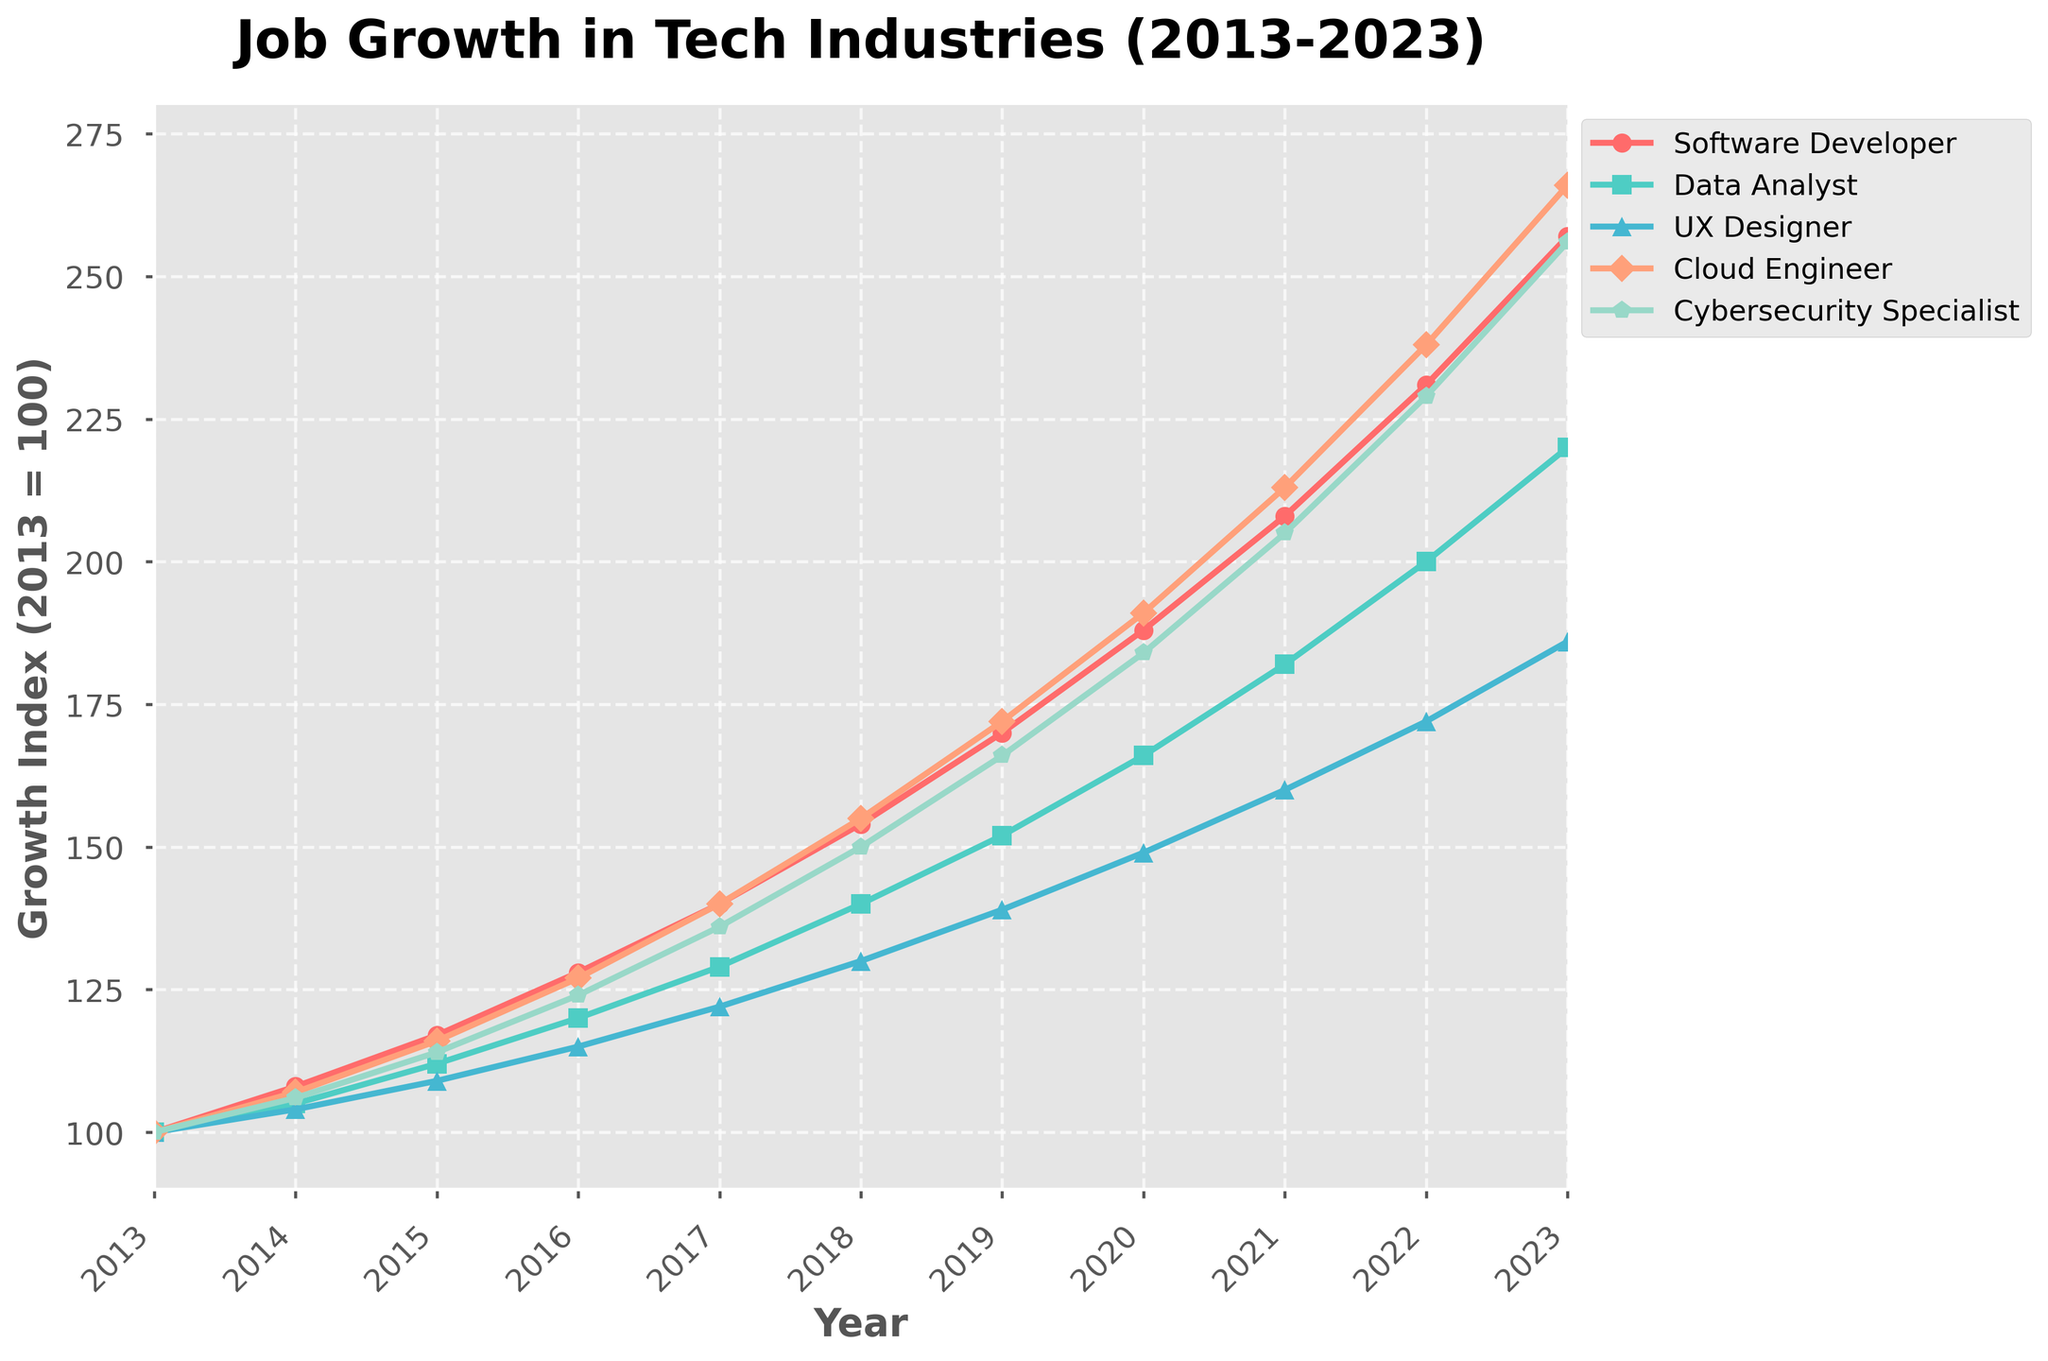What's the general trend for the growth of each job role from 2013 to 2023? To deduce the general trend for each job role over the decade, we need to look at the line plot for each role. Each line is consistently rising from 2013 to 2023. Thus, the general trend for all roles is an increase over time.
Answer: Increasing Which job role had the highest growth index in 2023? Check the line plot for each job role at the year 2023. The Software Developer role reaches the highest value, which is 257.
Answer: Software Developer By how much did the growth index of the Data Analyst role increase from 2013 to 2023? Subtract the Data Analyst index in 2013 from its index in 2023. The values are 220 in 2023 and 100 in 2013, so the increase is 220 - 100.
Answer: 120 Which role showed the least growth between 2013 and 2023? To find the role with the least growth, compare the growth values for all roles from 2013 to 2023. UX Designer grew from 100 to 186, which is the smallest increase (86).
Answer: UX Designer What was the average growth index of Cybersecurity Specialist over the decade? Sum the growth index values of Cybersecurity Specialist for each year from 2013 to 2023 and divide by the number of years (11). Calculation: (100+106+114+124+136+150+166+184+205+229+256)/11 = 1527/11.
Answer: 138.82 In which year did the Cloud Engineer index surpass 200 for the first time? Look at the Cloud Engineer role's plot line to identify the first year it surpassed 200. This crossing occurs first in 2021.
Answer: 2021 Which job role had the fastest acceleration in growth between 2019 and 2023? Compare the slopes of the plot lines between 2019 and 2023 across all roles. The steeper the slope, the faster the growth. The Software Developer role shows the steepest slope, indicating the fastest acceleration.
Answer: Software Developer Did the UX Designer role ever surpass the Data Analyst role in growth index over the decade? Compare the UX Designer and Data Analyst plot lines year by year. The UX Designer index never surpasses that of the Data Analyst role at any point from 2013 to 2023.
Answer: No By what percentage did the Cloud Engineer index increase from 2015 to 2023? Calculate the percentage increase from 2015 (116) to 2023 (266) for the Cloud Engineer role: (266 - 116) / 116 * 100% = 150 / 116 * 100%.
Answer: Approximately 129.31% What is the difference in growth index between the highest and lowest job roles in 2023? Find the range in 2023 by identifying the highest (Software Developer: 257) and lowest (UX Designer: 186) values and subtracting them: 257 - 186.
Answer: 71 